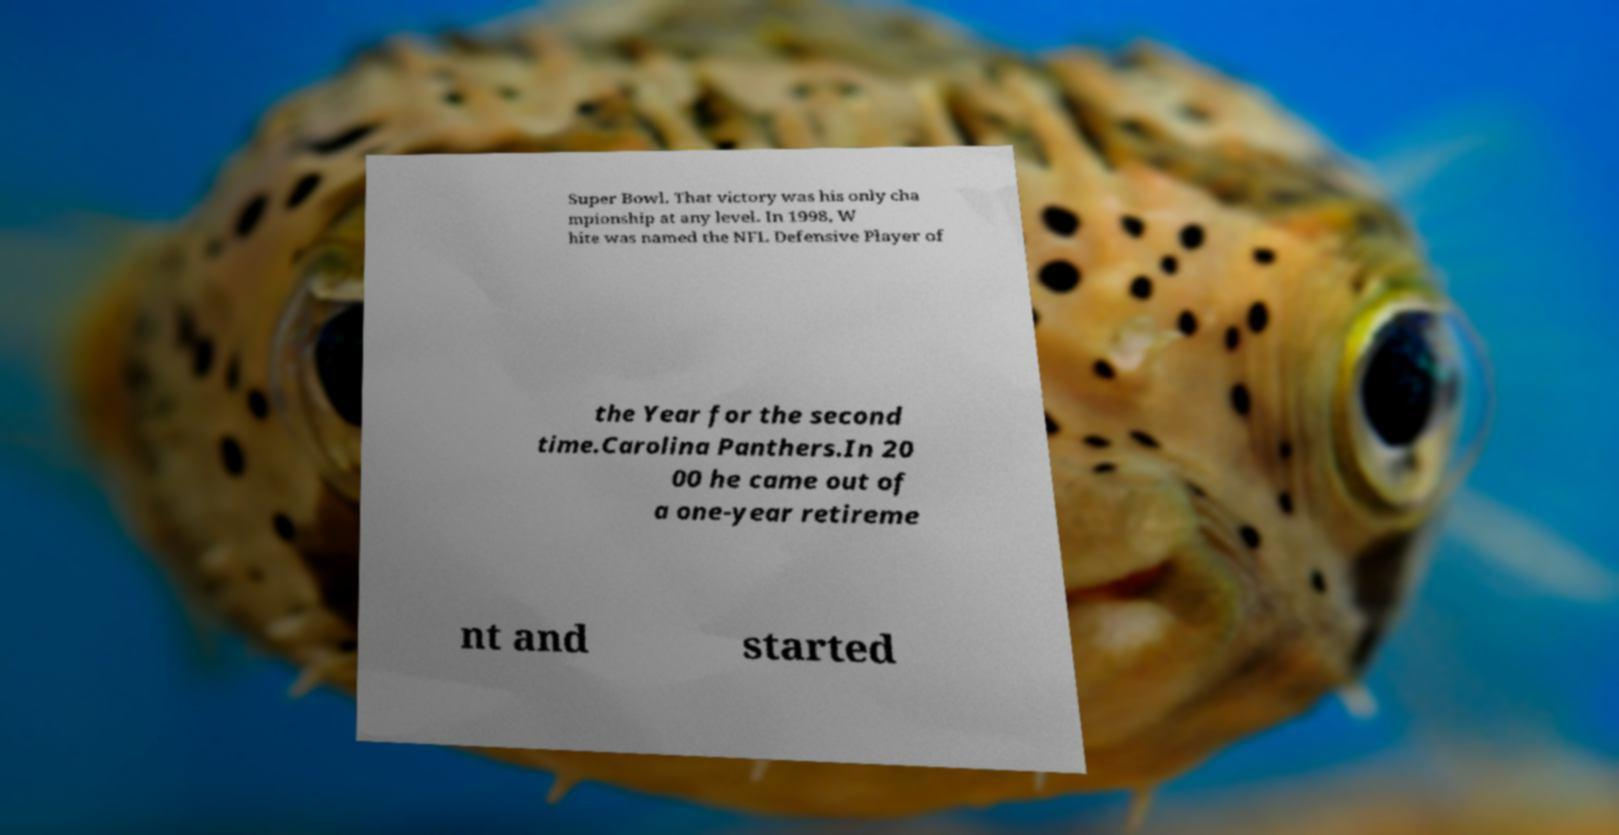Could you assist in decoding the text presented in this image and type it out clearly? Super Bowl. That victory was his only cha mpionship at any level. In 1998, W hite was named the NFL Defensive Player of the Year for the second time.Carolina Panthers.In 20 00 he came out of a one-year retireme nt and started 